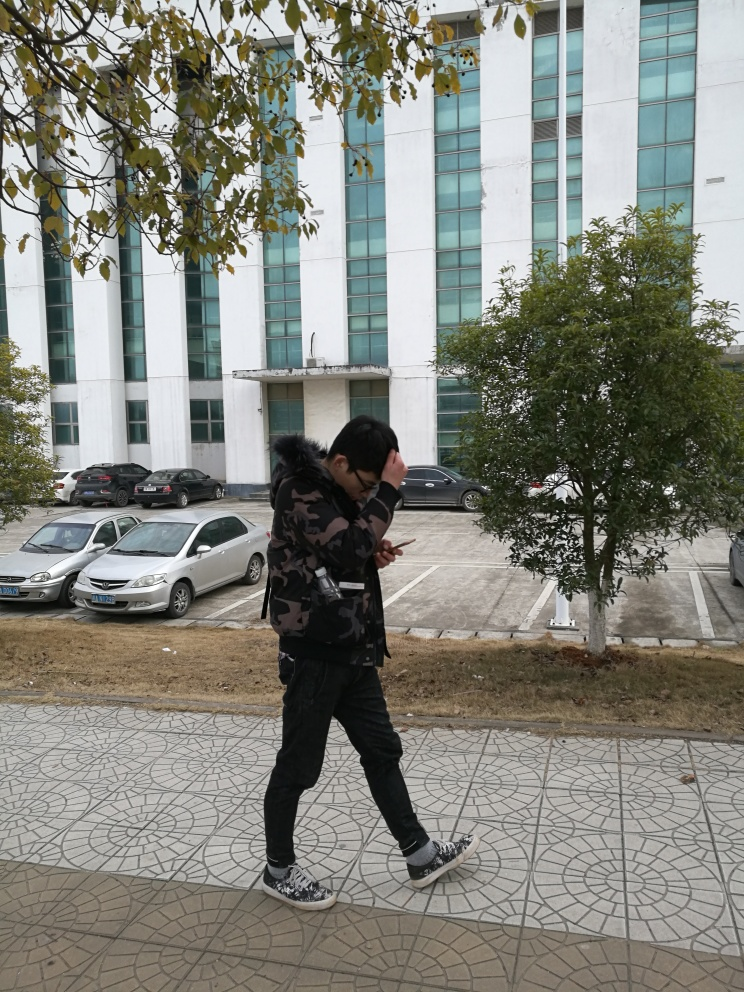What could be the purpose of the person’s gesture covering their face? The person might be shielding their eyes from the sun, suggesting a natural reflex to reduce glare or brightness. It also could be an attempt to maintain privacy or avoid having their face shown in the photograph. 